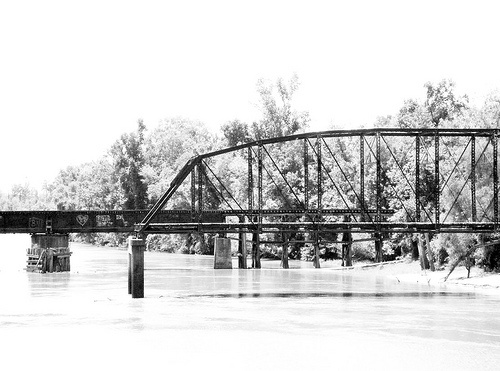Describe the objects in this image and their specific colors. I can see a train in white, black, gray, darkgray, and lightgray tones in this image. 